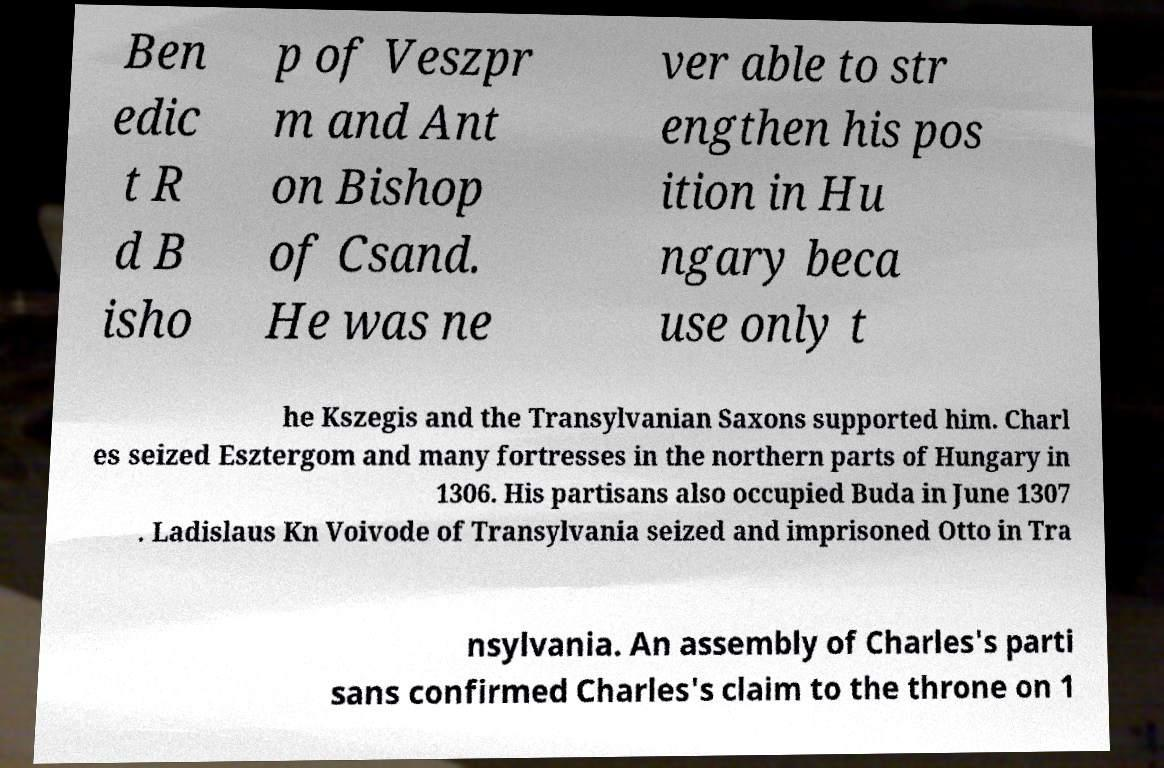I need the written content from this picture converted into text. Can you do that? Ben edic t R d B isho p of Veszpr m and Ant on Bishop of Csand. He was ne ver able to str engthen his pos ition in Hu ngary beca use only t he Kszegis and the Transylvanian Saxons supported him. Charl es seized Esztergom and many fortresses in the northern parts of Hungary in 1306. His partisans also occupied Buda in June 1307 . Ladislaus Kn Voivode of Transylvania seized and imprisoned Otto in Tra nsylvania. An assembly of Charles's parti sans confirmed Charles's claim to the throne on 1 